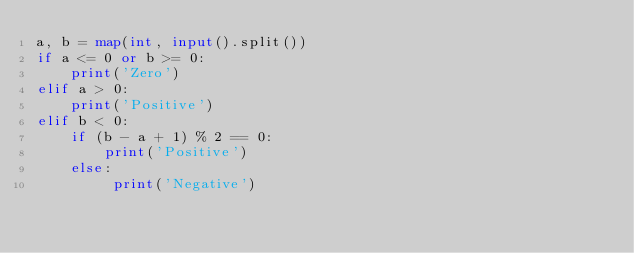<code> <loc_0><loc_0><loc_500><loc_500><_Python_>a, b = map(int, input().split())
if a <= 0 or b >= 0:
    print('Zero')
elif a > 0:
    print('Positive')
elif b < 0:
    if (b - a + 1) % 2 == 0:
        print('Positive')
    else:
         print('Negative')
</code> 